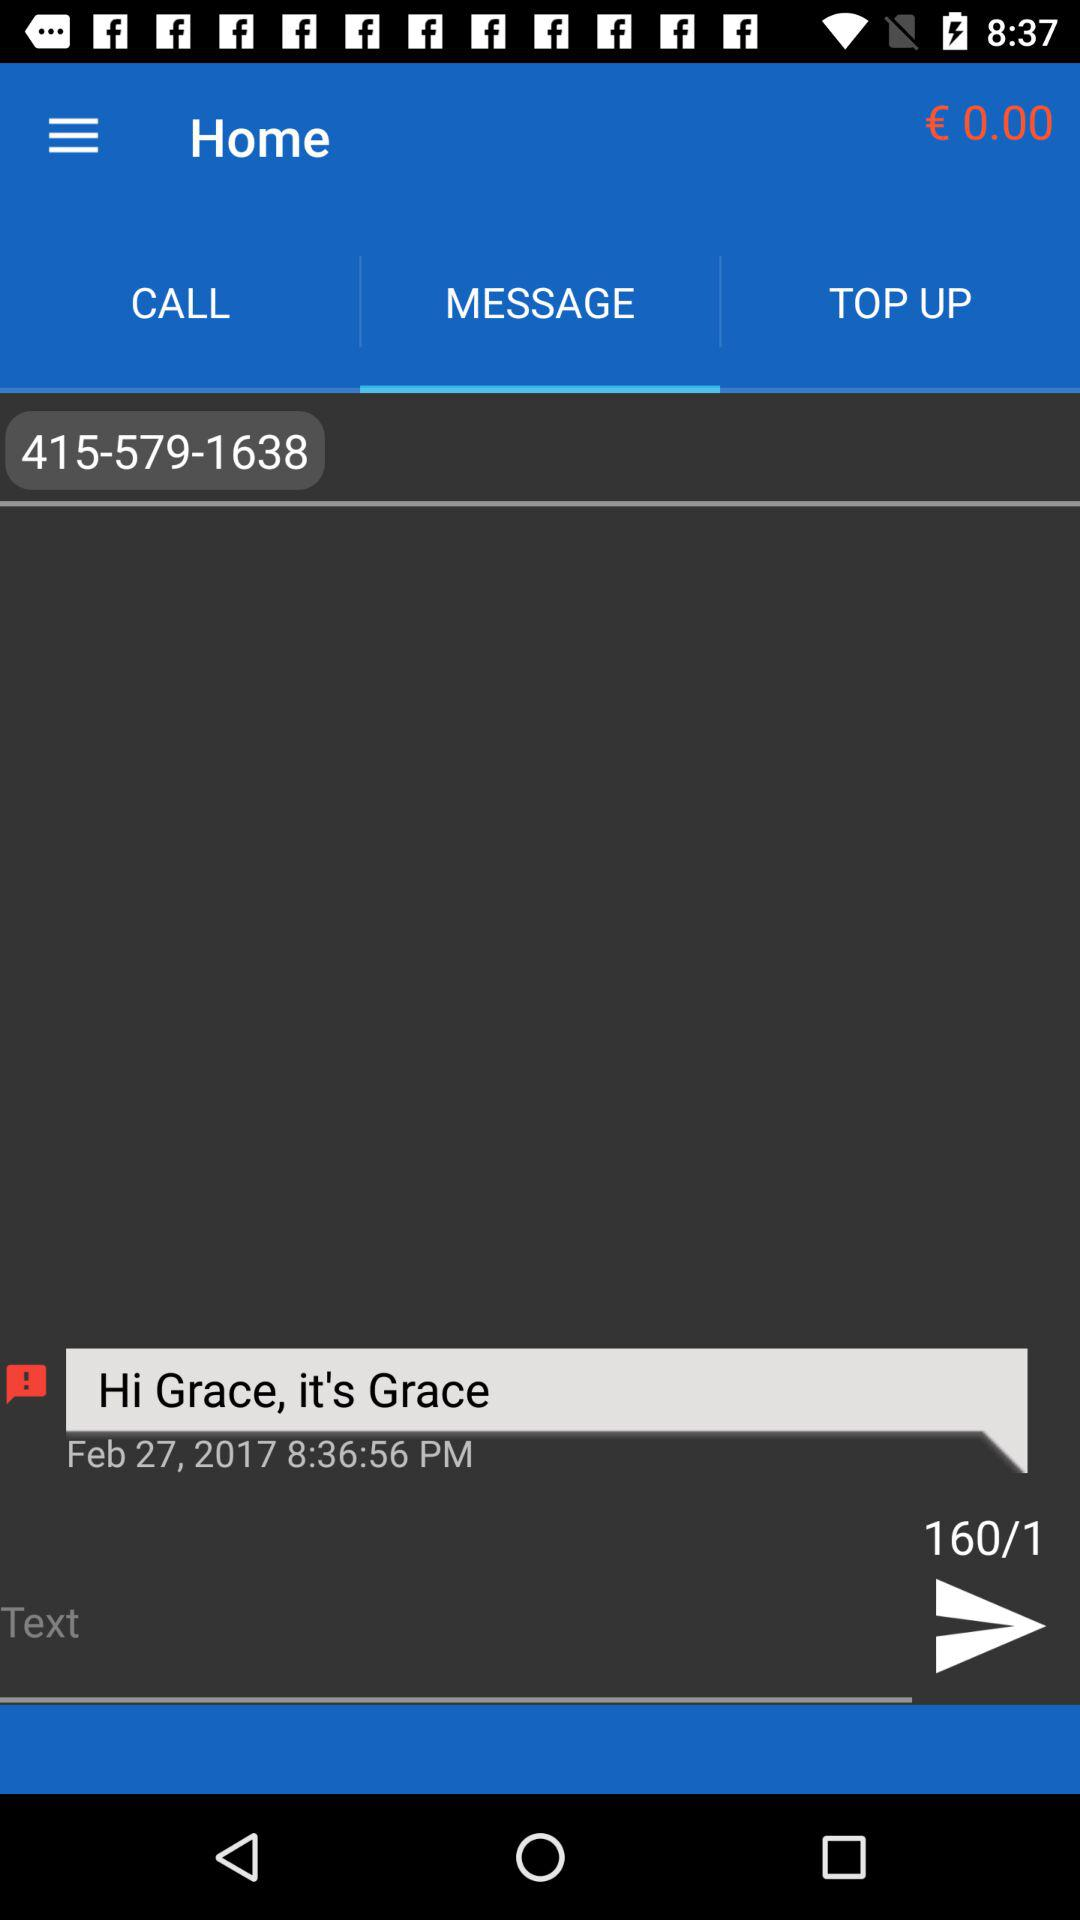What is the name of the person? The name of the person is Grace. 